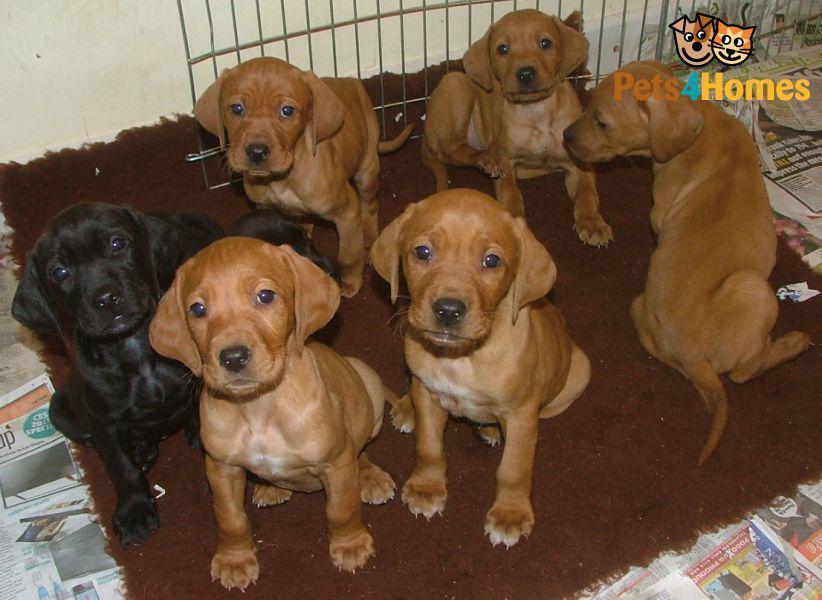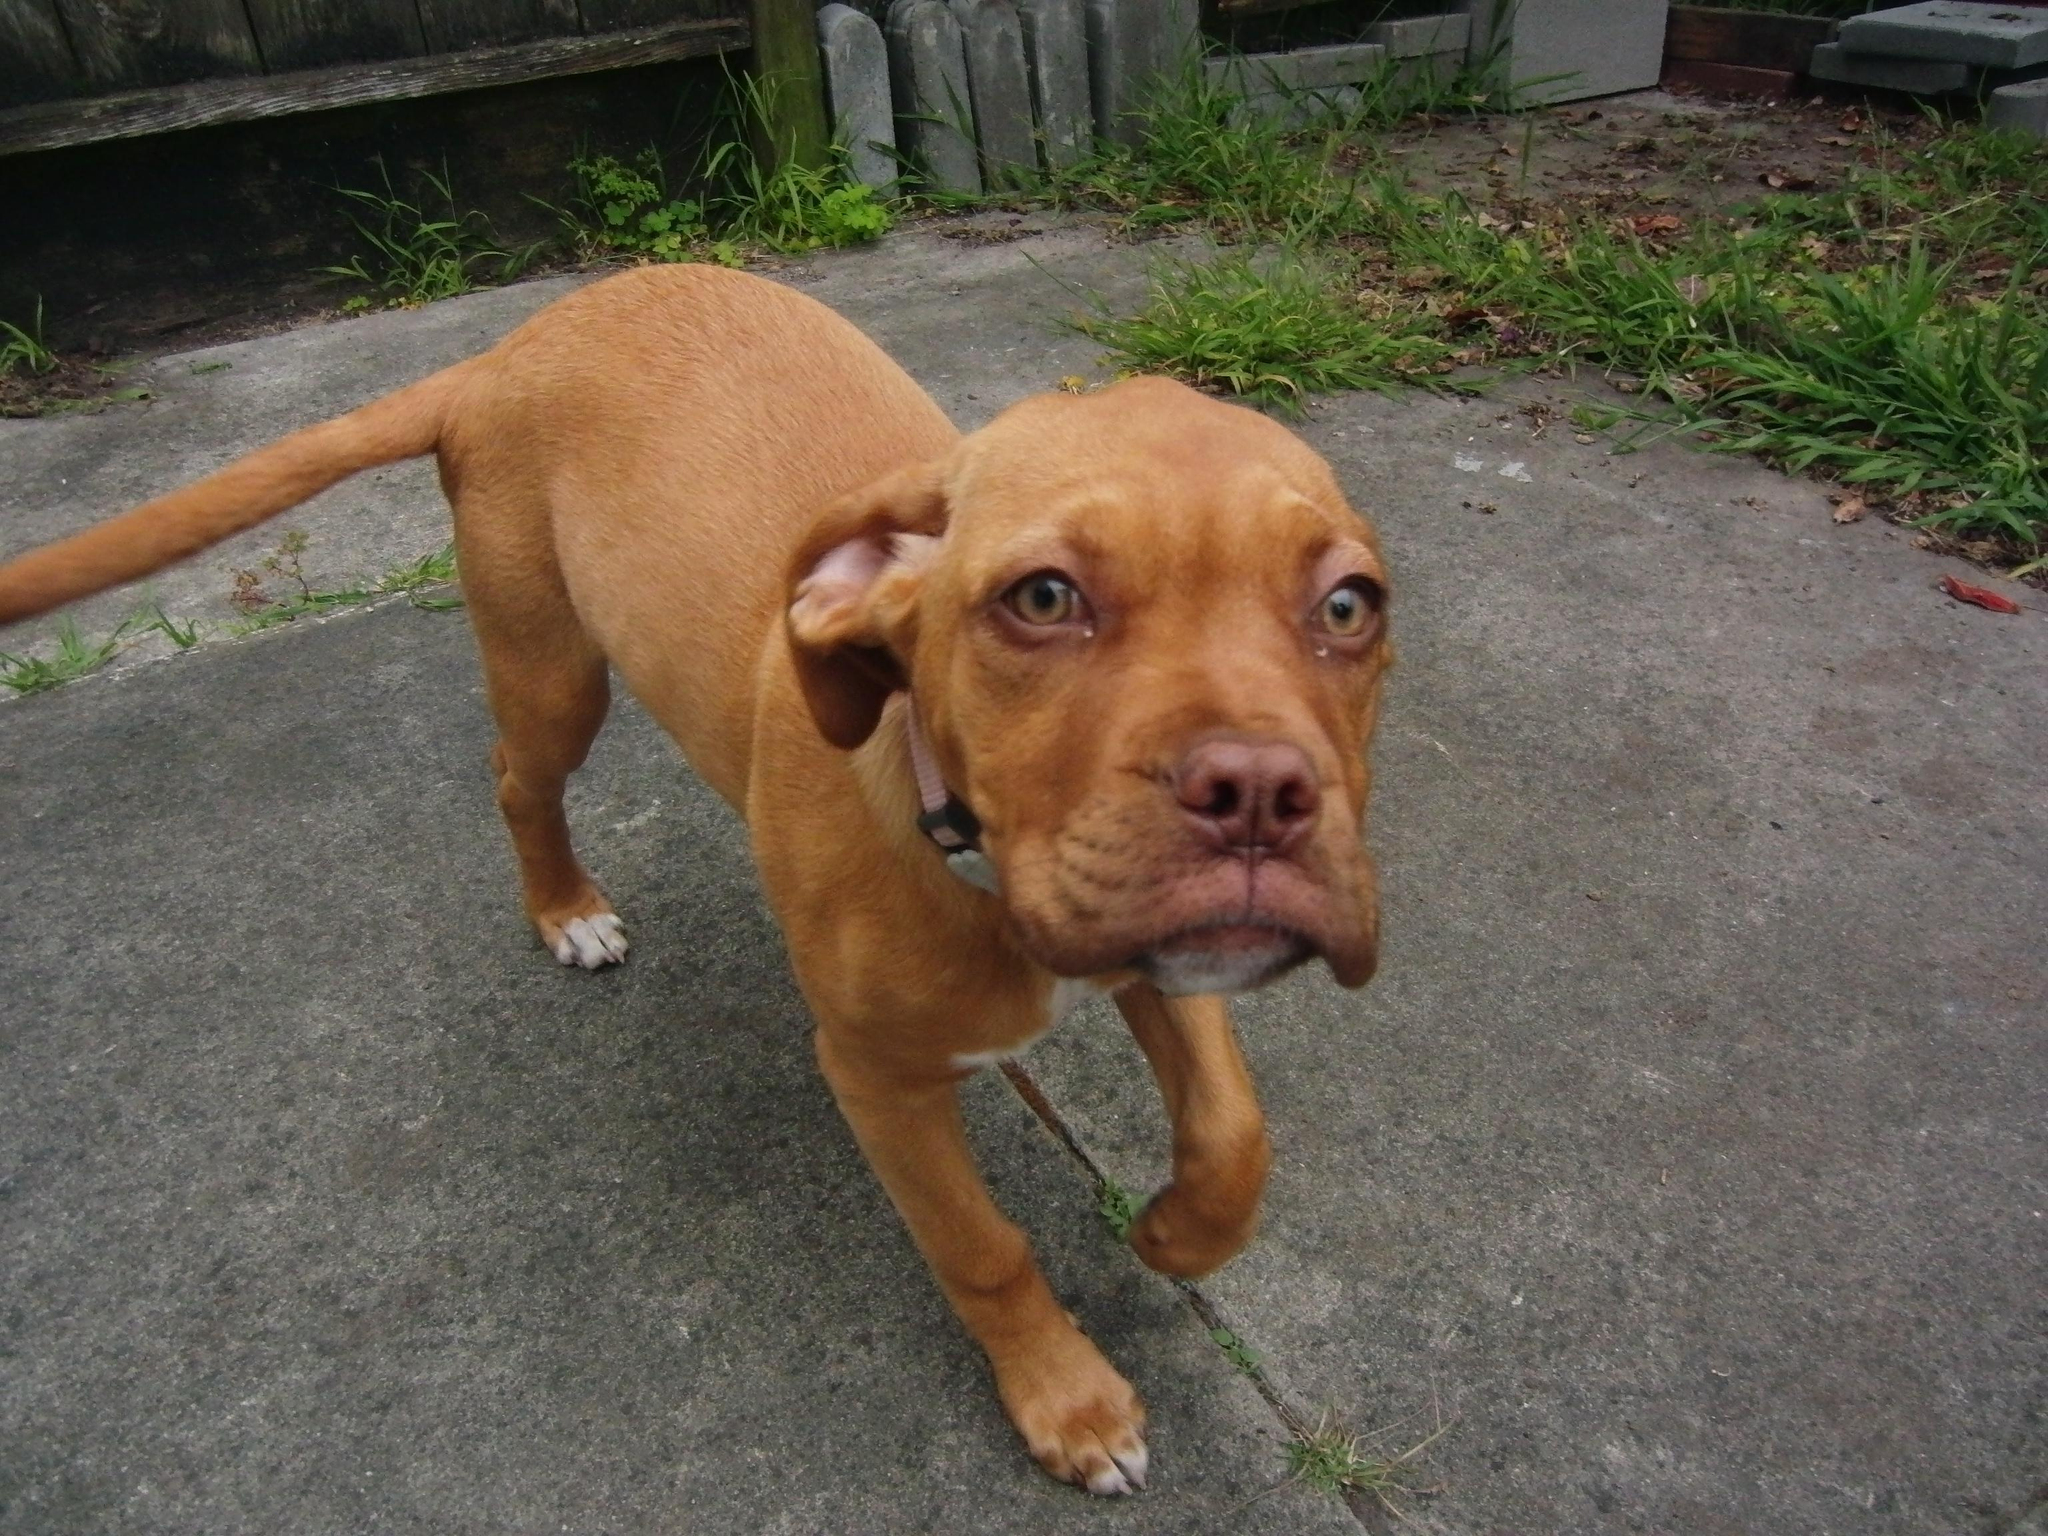The first image is the image on the left, the second image is the image on the right. Evaluate the accuracy of this statement regarding the images: "The left image contains at least two dogs.". Is it true? Answer yes or no. Yes. The first image is the image on the left, the second image is the image on the right. For the images shown, is this caption "The dogs in each of the images are outside." true? Answer yes or no. No. 